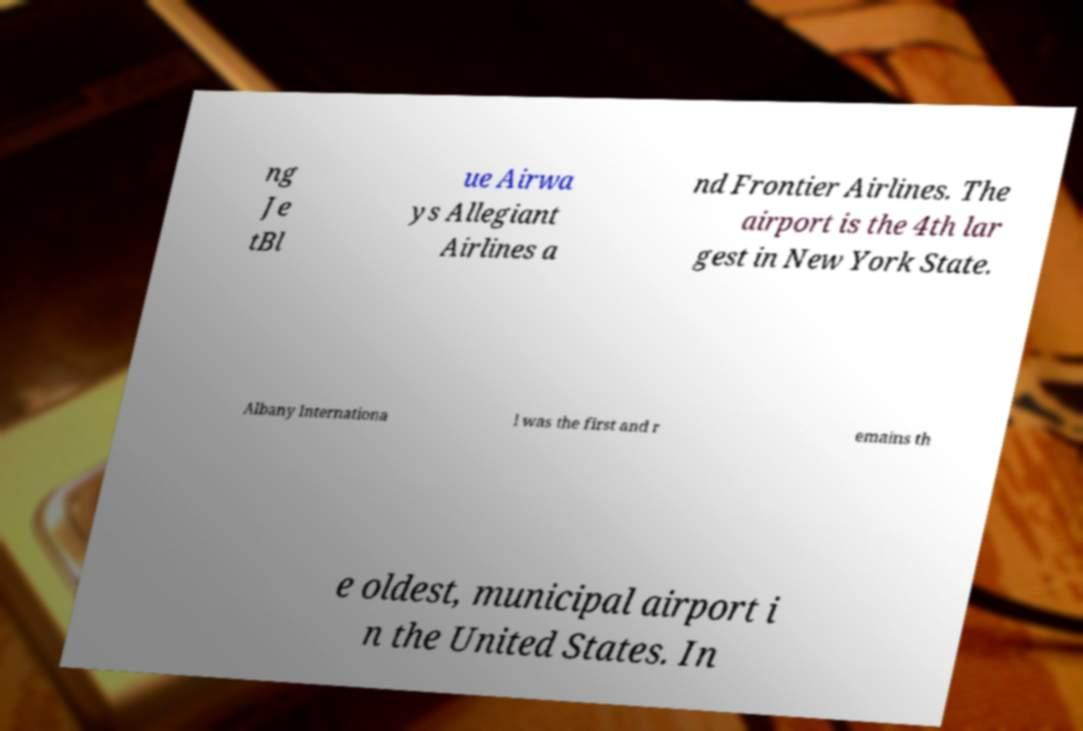Can you read and provide the text displayed in the image?This photo seems to have some interesting text. Can you extract and type it out for me? ng Je tBl ue Airwa ys Allegiant Airlines a nd Frontier Airlines. The airport is the 4th lar gest in New York State. Albany Internationa l was the first and r emains th e oldest, municipal airport i n the United States. In 